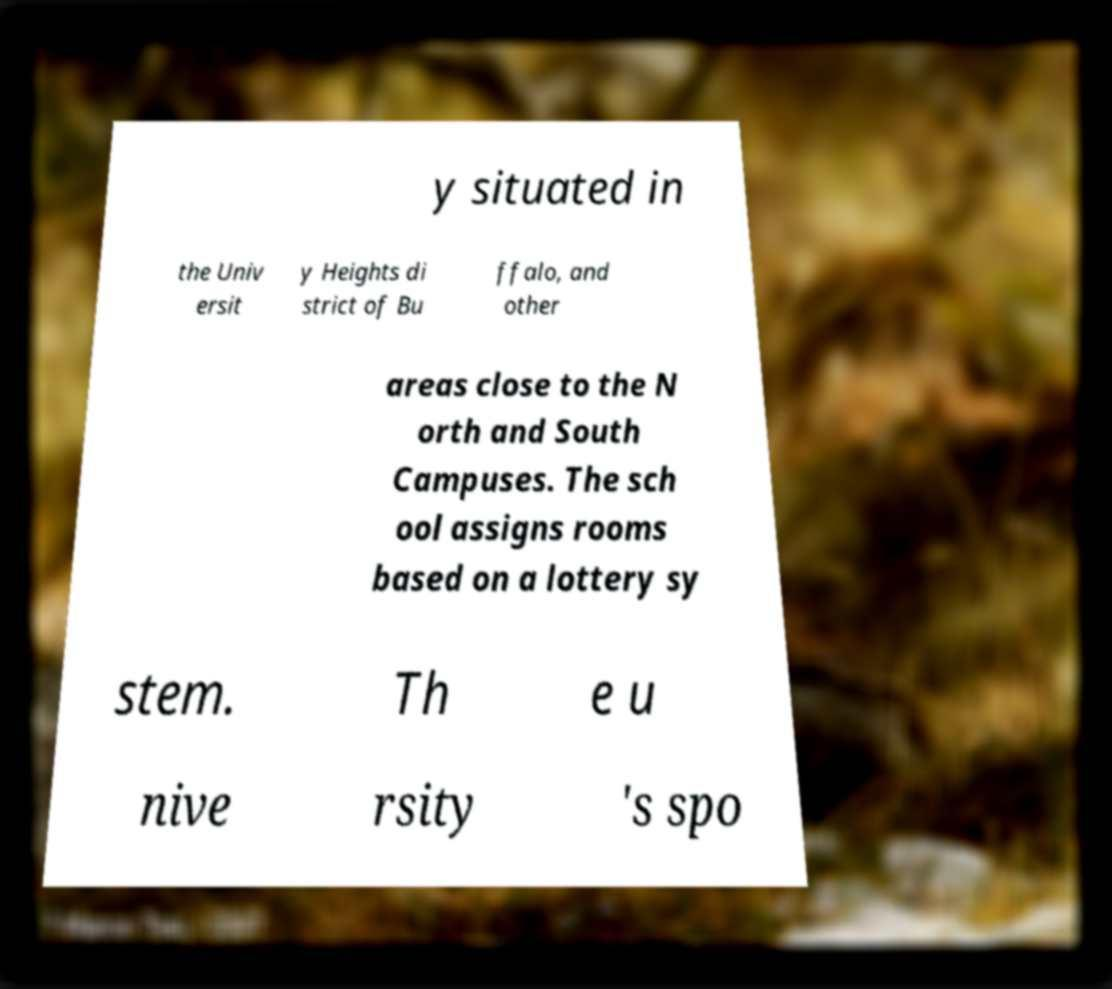Could you assist in decoding the text presented in this image and type it out clearly? y situated in the Univ ersit y Heights di strict of Bu ffalo, and other areas close to the N orth and South Campuses. The sch ool assigns rooms based on a lottery sy stem. Th e u nive rsity 's spo 